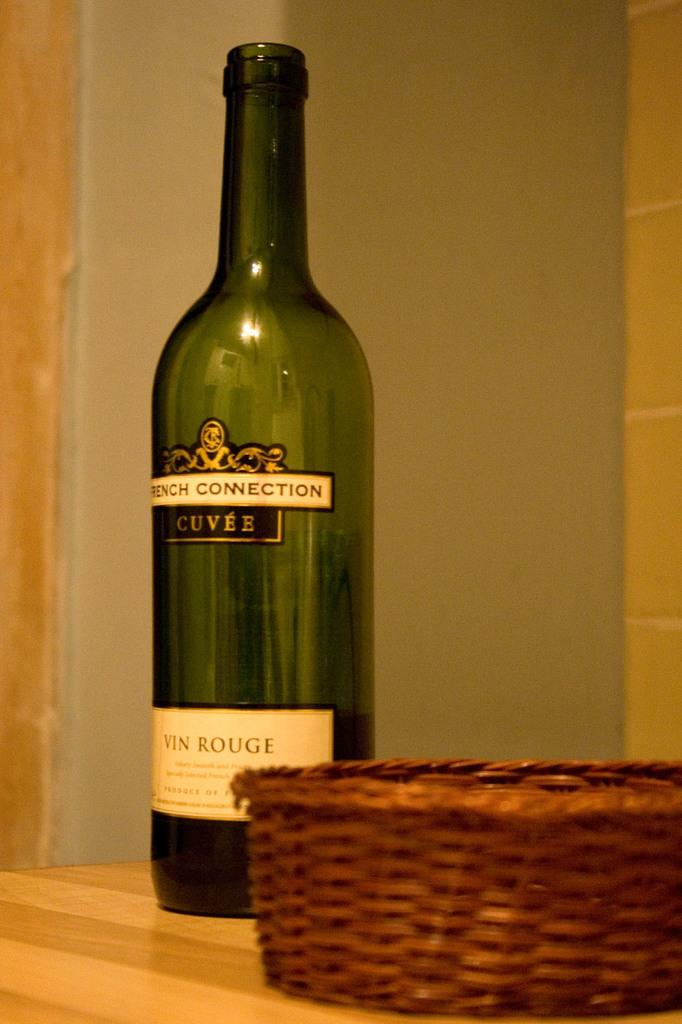<image>
Describe the image concisely. A bottle of wine next to a basket, the wine reads French Connection. 